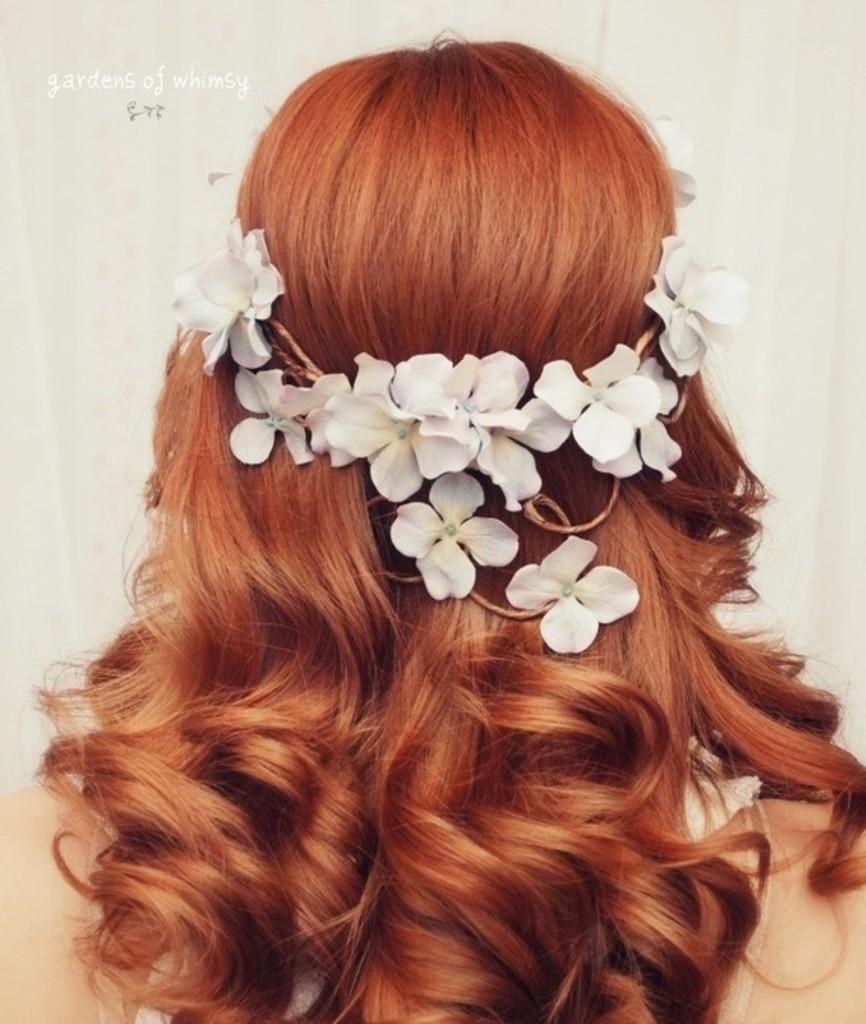Who is the main subject in the image? There is a woman in the image. Can you describe the woman's hairstyle? The woman has a specific hairstyle. What accessory is the woman wearing on her head? The woman is wearing a floral crown. What type of cream is being used to paint the frame in the image? There is no frame or painting present in the image, so there is no cream being used. 